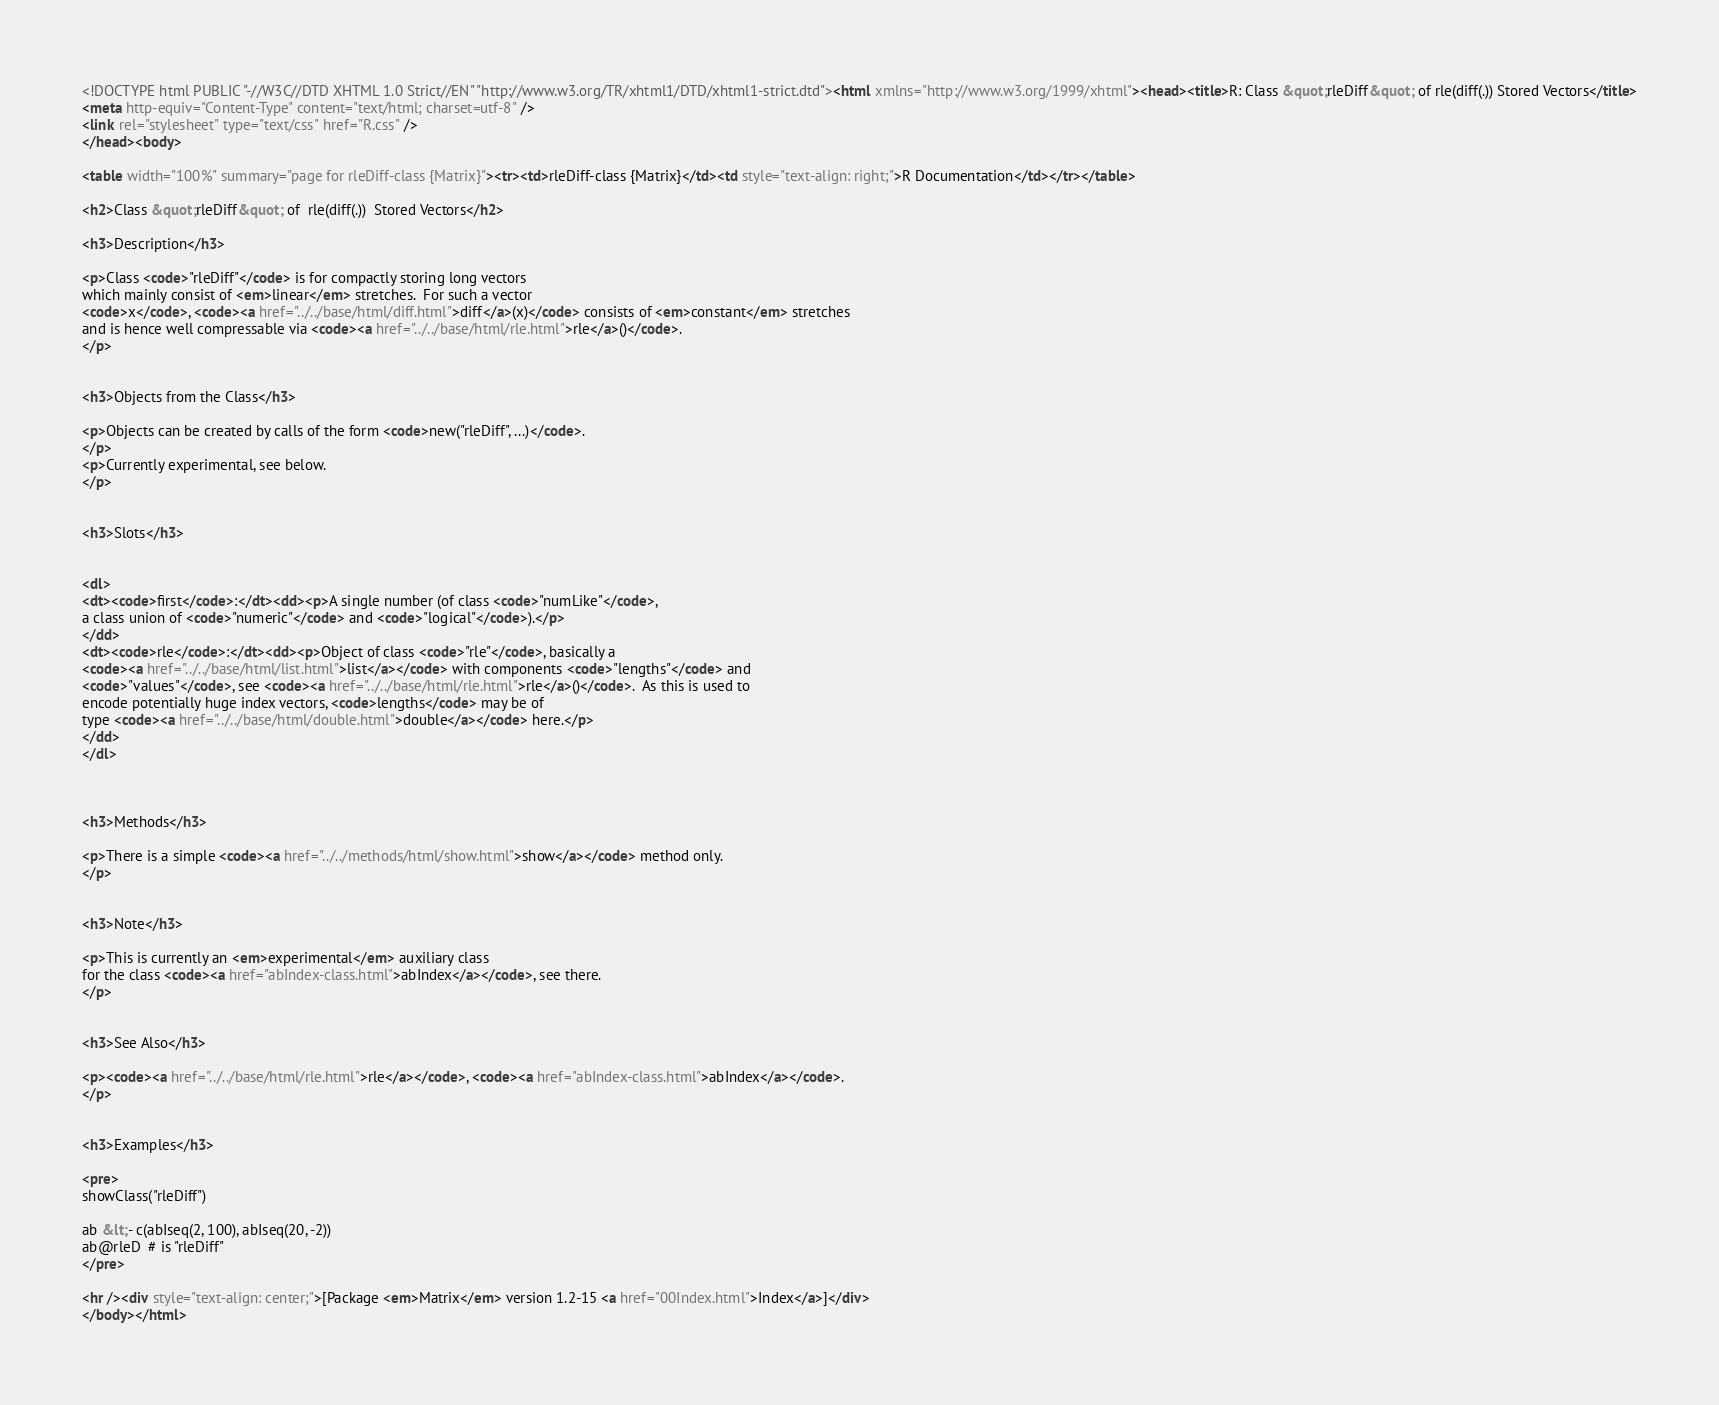<code> <loc_0><loc_0><loc_500><loc_500><_HTML_><!DOCTYPE html PUBLIC "-//W3C//DTD XHTML 1.0 Strict//EN" "http://www.w3.org/TR/xhtml1/DTD/xhtml1-strict.dtd"><html xmlns="http://www.w3.org/1999/xhtml"><head><title>R: Class &quot;rleDiff&quot; of rle(diff(.)) Stored Vectors</title>
<meta http-equiv="Content-Type" content="text/html; charset=utf-8" />
<link rel="stylesheet" type="text/css" href="R.css" />
</head><body>

<table width="100%" summary="page for rleDiff-class {Matrix}"><tr><td>rleDiff-class {Matrix}</td><td style="text-align: right;">R Documentation</td></tr></table>

<h2>Class &quot;rleDiff&quot; of  rle(diff(.))  Stored Vectors</h2>

<h3>Description</h3>

<p>Class <code>"rleDiff"</code> is for compactly storing long vectors
which mainly consist of <em>linear</em> stretches.  For such a vector
<code>x</code>, <code><a href="../../base/html/diff.html">diff</a>(x)</code> consists of <em>constant</em> stretches
and is hence well compressable via <code><a href="../../base/html/rle.html">rle</a>()</code>.
</p>


<h3>Objects from the Class</h3>

<p>Objects can be created by calls of the form <code>new("rleDiff", ...)</code>.
</p>
<p>Currently experimental, see below.
</p>


<h3>Slots</h3>


<dl>
<dt><code>first</code>:</dt><dd><p>A single number (of class <code>"numLike"</code>,
a class union of <code>"numeric"</code> and <code>"logical"</code>).</p>
</dd>
<dt><code>rle</code>:</dt><dd><p>Object of class <code>"rle"</code>, basically a
<code><a href="../../base/html/list.html">list</a></code> with components <code>"lengths"</code> and
<code>"values"</code>, see <code><a href="../../base/html/rle.html">rle</a>()</code>.  As this is used to
encode potentially huge index vectors, <code>lengths</code> may be of
type <code><a href="../../base/html/double.html">double</a></code> here.</p>
</dd>
</dl>



<h3>Methods</h3>

<p>There is a simple <code><a href="../../methods/html/show.html">show</a></code> method only.
</p>


<h3>Note</h3>

<p>This is currently an <em>experimental</em> auxiliary class
for the class <code><a href="abIndex-class.html">abIndex</a></code>, see there.
</p>


<h3>See Also</h3>

<p><code><a href="../../base/html/rle.html">rle</a></code>, <code><a href="abIndex-class.html">abIndex</a></code>.
</p>


<h3>Examples</h3>

<pre>
showClass("rleDiff")

ab &lt;- c(abIseq(2, 100), abIseq(20, -2))
ab@rleD  # is "rleDiff"
</pre>

<hr /><div style="text-align: center;">[Package <em>Matrix</em> version 1.2-15 <a href="00Index.html">Index</a>]</div>
</body></html>
</code> 